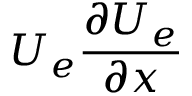<formula> <loc_0><loc_0><loc_500><loc_500>U _ { e } \frac { \partial U _ { e } } { \partial x }</formula> 